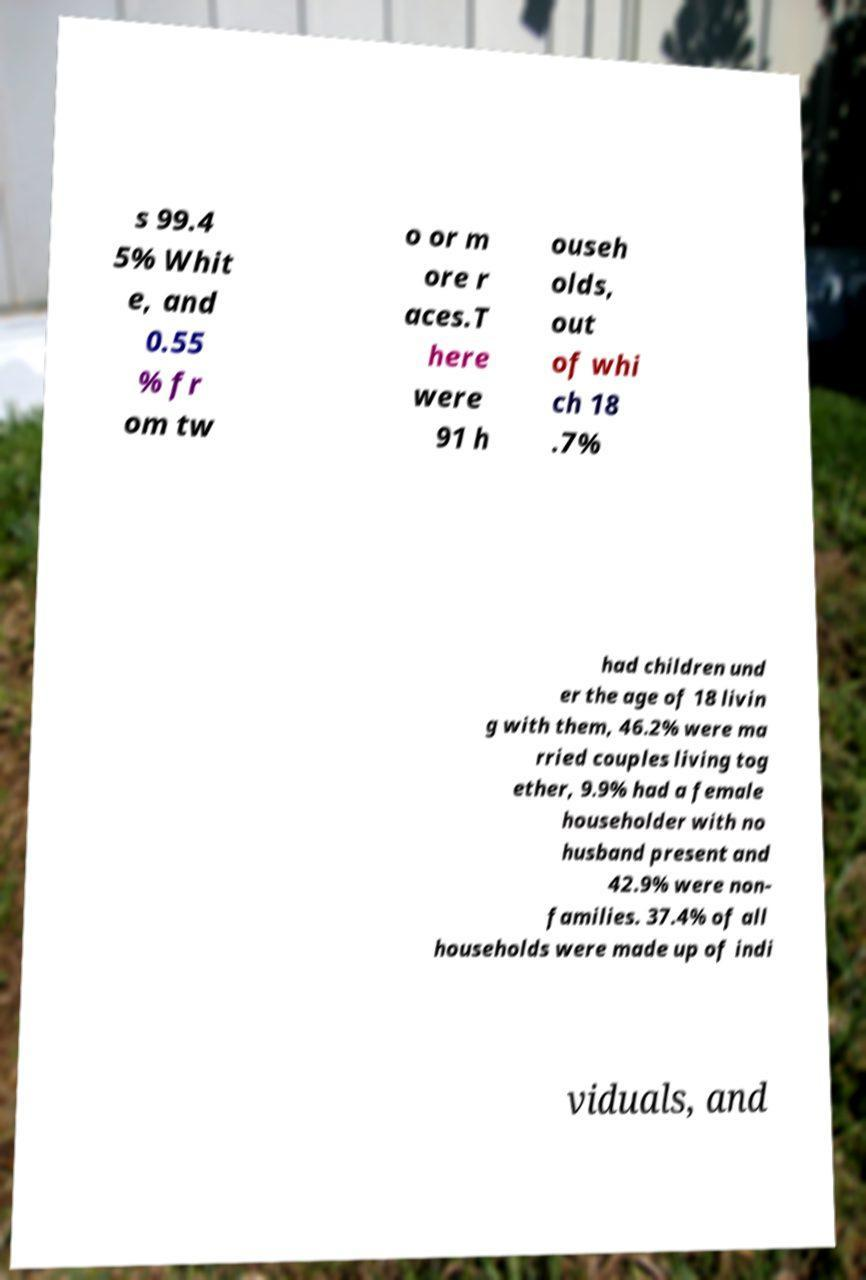I need the written content from this picture converted into text. Can you do that? s 99.4 5% Whit e, and 0.55 % fr om tw o or m ore r aces.T here were 91 h ouseh olds, out of whi ch 18 .7% had children und er the age of 18 livin g with them, 46.2% were ma rried couples living tog ether, 9.9% had a female householder with no husband present and 42.9% were non- families. 37.4% of all households were made up of indi viduals, and 